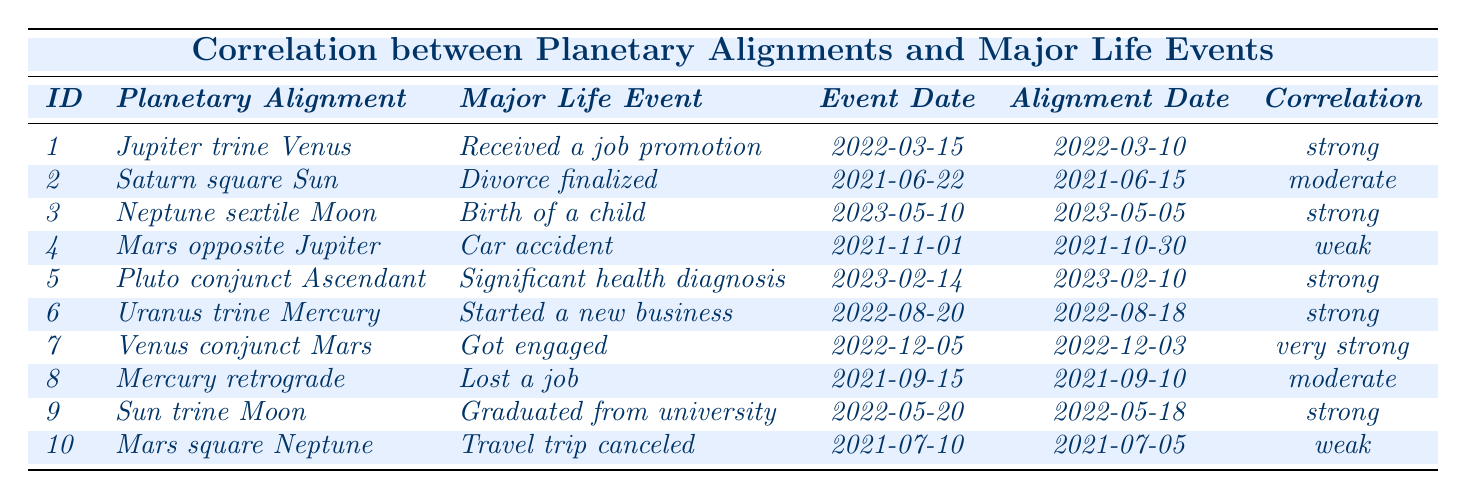What's the most common correlation strength in the data? There are several entries to analyze. The correlation strengths listed are: strong (5), moderate (3), weak (2), and very strong (1). The highest frequency is for "strong," occurring 5 times.
Answer: strong Which participant experienced a major life event closest to their planetary alignment? The events are dated and can be compared. The events for participant 3 (birth of a child) and participant 9 (graduation) occurred just 5 days after their alignment date. No other events were closer than this.
Answer: participant 3 and participant 9 What major life event is associated with the planetary alignment "Venus conjunct Mars"? Referring to the table, participant 7 associated with "Venus conjunct Mars" experienced getting engaged.
Answer: Got engaged How many participants experienced strong correlations with their major life events? By checking the list, there are 5 instances of "strong" listed under correlation strength across the data.
Answer: 5 Is there any participant with a weak correlation who experienced a positive life event? Participant 4 had a weak correlation and experienced a car accident, which isn't typically viewed as a positive life event. Thus, the answer is no positive events are associated with weak correlation.
Answer: No What is the total number of "major life events" that occurred in 2021? Scanning through the data, events from 2021 are: divorce, car accident, and job loss. This results in 3 events happening in that year.
Answer: 3 What is the correlation strength of the major life event "Graduated from university"? Looking at participant 9, the event "Graduated from university" has a correlation strength of "strong."
Answer: strong How many participants experienced a "very strong" correlation, and what was their major life event? The table shows only 1 instance of "very strong" correlation associated with participant 7, who got engaged.
Answer: 1 participant; got engaged Did any participant experience a major life event after a Mercury retrograde alignment? According to the table, participant 8 experienced job loss after a Mercury retrograde alignment. Hence, the answer is yes.
Answer: Yes Which major life event occurred most recently and what was the correlation strength for it? The most recent event listed is the "Birth of a child" on May 10, 2023, with a correlation strength of "strong."
Answer: Birth of a child; strong 